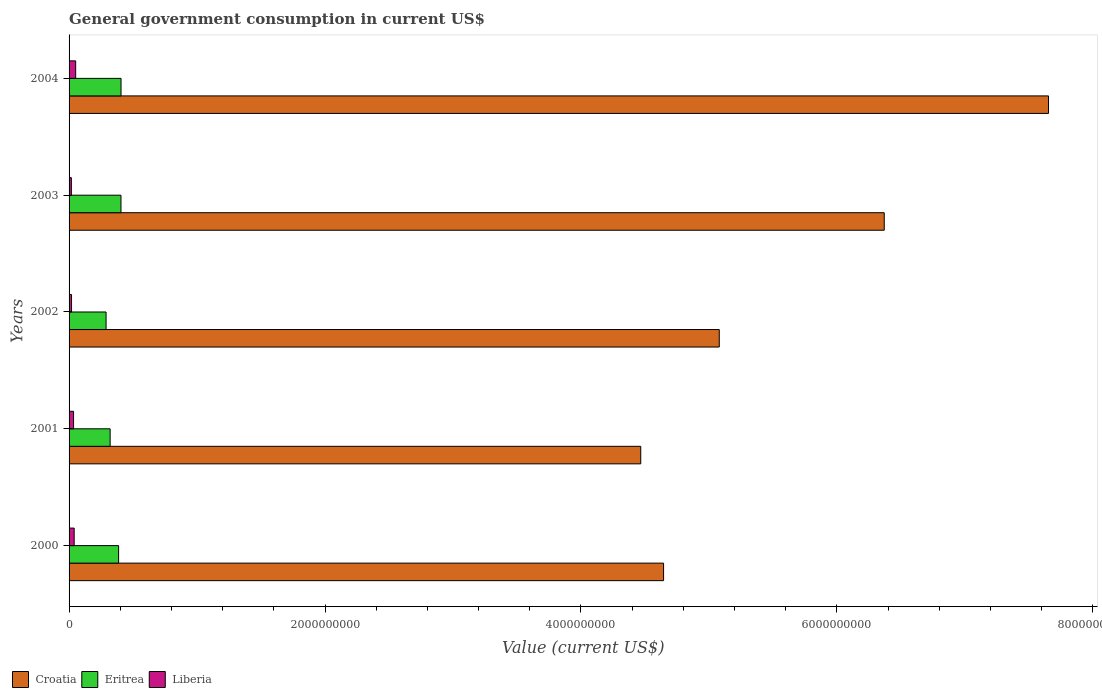How many different coloured bars are there?
Keep it short and to the point. 3. Are the number of bars per tick equal to the number of legend labels?
Provide a succinct answer. Yes. What is the government conusmption in Eritrea in 2002?
Your response must be concise. 2.89e+08. Across all years, what is the maximum government conusmption in Eritrea?
Make the answer very short. 4.06e+08. Across all years, what is the minimum government conusmption in Eritrea?
Keep it short and to the point. 2.89e+08. What is the total government conusmption in Eritrea in the graph?
Your answer should be compact. 1.81e+09. What is the difference between the government conusmption in Liberia in 2001 and that in 2003?
Provide a short and direct response. 1.72e+07. What is the difference between the government conusmption in Liberia in 2000 and the government conusmption in Eritrea in 2002?
Make the answer very short. -2.49e+08. What is the average government conusmption in Eritrea per year?
Your answer should be compact. 3.62e+08. In the year 2000, what is the difference between the government conusmption in Croatia and government conusmption in Eritrea?
Your answer should be compact. 4.26e+09. What is the ratio of the government conusmption in Eritrea in 2000 to that in 2001?
Offer a terse response. 1.21. Is the government conusmption in Eritrea in 2001 less than that in 2004?
Provide a short and direct response. Yes. Is the difference between the government conusmption in Croatia in 2001 and 2003 greater than the difference between the government conusmption in Eritrea in 2001 and 2003?
Ensure brevity in your answer.  No. What is the difference between the highest and the second highest government conusmption in Liberia?
Offer a terse response. 1.18e+07. What is the difference between the highest and the lowest government conusmption in Croatia?
Your response must be concise. 3.19e+09. In how many years, is the government conusmption in Croatia greater than the average government conusmption in Croatia taken over all years?
Ensure brevity in your answer.  2. What does the 2nd bar from the top in 2001 represents?
Offer a very short reply. Eritrea. What does the 1st bar from the bottom in 2002 represents?
Your response must be concise. Croatia. Is it the case that in every year, the sum of the government conusmption in Eritrea and government conusmption in Liberia is greater than the government conusmption in Croatia?
Your answer should be compact. No. Are all the bars in the graph horizontal?
Provide a succinct answer. Yes. What is the difference between two consecutive major ticks on the X-axis?
Give a very brief answer. 2.00e+09. Are the values on the major ticks of X-axis written in scientific E-notation?
Provide a short and direct response. No. Does the graph contain any zero values?
Provide a succinct answer. No. Does the graph contain grids?
Provide a succinct answer. No. How are the legend labels stacked?
Offer a very short reply. Horizontal. What is the title of the graph?
Provide a succinct answer. General government consumption in current US$. Does "Egypt, Arab Rep." appear as one of the legend labels in the graph?
Provide a short and direct response. No. What is the label or title of the X-axis?
Offer a very short reply. Value (current US$). What is the label or title of the Y-axis?
Your answer should be very brief. Years. What is the Value (current US$) of Croatia in 2000?
Provide a succinct answer. 4.65e+09. What is the Value (current US$) of Eritrea in 2000?
Your answer should be compact. 3.87e+08. What is the Value (current US$) of Liberia in 2000?
Give a very brief answer. 3.99e+07. What is the Value (current US$) of Croatia in 2001?
Make the answer very short. 4.47e+09. What is the Value (current US$) in Eritrea in 2001?
Provide a succinct answer. 3.21e+08. What is the Value (current US$) of Liberia in 2001?
Your answer should be very brief. 3.51e+07. What is the Value (current US$) in Croatia in 2002?
Give a very brief answer. 5.08e+09. What is the Value (current US$) of Eritrea in 2002?
Your answer should be compact. 2.89e+08. What is the Value (current US$) in Liberia in 2002?
Give a very brief answer. 1.92e+07. What is the Value (current US$) in Croatia in 2003?
Ensure brevity in your answer.  6.37e+09. What is the Value (current US$) of Eritrea in 2003?
Give a very brief answer. 4.06e+08. What is the Value (current US$) in Liberia in 2003?
Your response must be concise. 1.79e+07. What is the Value (current US$) in Croatia in 2004?
Your answer should be very brief. 7.65e+09. What is the Value (current US$) in Eritrea in 2004?
Offer a very short reply. 4.06e+08. What is the Value (current US$) of Liberia in 2004?
Your response must be concise. 5.16e+07. Across all years, what is the maximum Value (current US$) of Croatia?
Provide a short and direct response. 7.65e+09. Across all years, what is the maximum Value (current US$) in Eritrea?
Your response must be concise. 4.06e+08. Across all years, what is the maximum Value (current US$) in Liberia?
Keep it short and to the point. 5.16e+07. Across all years, what is the minimum Value (current US$) of Croatia?
Your answer should be compact. 4.47e+09. Across all years, what is the minimum Value (current US$) in Eritrea?
Give a very brief answer. 2.89e+08. Across all years, what is the minimum Value (current US$) in Liberia?
Offer a very short reply. 1.79e+07. What is the total Value (current US$) of Croatia in the graph?
Offer a very short reply. 2.82e+1. What is the total Value (current US$) in Eritrea in the graph?
Keep it short and to the point. 1.81e+09. What is the total Value (current US$) in Liberia in the graph?
Provide a succinct answer. 1.64e+08. What is the difference between the Value (current US$) of Croatia in 2000 and that in 2001?
Offer a very short reply. 1.78e+08. What is the difference between the Value (current US$) of Eritrea in 2000 and that in 2001?
Keep it short and to the point. 6.62e+07. What is the difference between the Value (current US$) in Liberia in 2000 and that in 2001?
Your answer should be compact. 4.77e+06. What is the difference between the Value (current US$) of Croatia in 2000 and that in 2002?
Provide a short and direct response. -4.35e+08. What is the difference between the Value (current US$) of Eritrea in 2000 and that in 2002?
Provide a short and direct response. 9.78e+07. What is the difference between the Value (current US$) of Liberia in 2000 and that in 2002?
Keep it short and to the point. 2.06e+07. What is the difference between the Value (current US$) in Croatia in 2000 and that in 2003?
Your response must be concise. -1.72e+09. What is the difference between the Value (current US$) of Eritrea in 2000 and that in 2003?
Your response must be concise. -1.85e+07. What is the difference between the Value (current US$) in Liberia in 2000 and that in 2003?
Ensure brevity in your answer.  2.19e+07. What is the difference between the Value (current US$) in Croatia in 2000 and that in 2004?
Provide a succinct answer. -3.01e+09. What is the difference between the Value (current US$) of Eritrea in 2000 and that in 2004?
Your answer should be very brief. -1.90e+07. What is the difference between the Value (current US$) of Liberia in 2000 and that in 2004?
Keep it short and to the point. -1.18e+07. What is the difference between the Value (current US$) of Croatia in 2001 and that in 2002?
Your answer should be compact. -6.14e+08. What is the difference between the Value (current US$) in Eritrea in 2001 and that in 2002?
Ensure brevity in your answer.  3.17e+07. What is the difference between the Value (current US$) of Liberia in 2001 and that in 2002?
Your answer should be compact. 1.58e+07. What is the difference between the Value (current US$) of Croatia in 2001 and that in 2003?
Your response must be concise. -1.90e+09. What is the difference between the Value (current US$) of Eritrea in 2001 and that in 2003?
Offer a very short reply. -8.47e+07. What is the difference between the Value (current US$) of Liberia in 2001 and that in 2003?
Provide a short and direct response. 1.72e+07. What is the difference between the Value (current US$) of Croatia in 2001 and that in 2004?
Keep it short and to the point. -3.19e+09. What is the difference between the Value (current US$) in Eritrea in 2001 and that in 2004?
Your response must be concise. -8.52e+07. What is the difference between the Value (current US$) of Liberia in 2001 and that in 2004?
Your answer should be compact. -1.66e+07. What is the difference between the Value (current US$) in Croatia in 2002 and that in 2003?
Make the answer very short. -1.29e+09. What is the difference between the Value (current US$) of Eritrea in 2002 and that in 2003?
Provide a succinct answer. -1.16e+08. What is the difference between the Value (current US$) in Liberia in 2002 and that in 2003?
Offer a very short reply. 1.33e+06. What is the difference between the Value (current US$) of Croatia in 2002 and that in 2004?
Ensure brevity in your answer.  -2.57e+09. What is the difference between the Value (current US$) of Eritrea in 2002 and that in 2004?
Offer a terse response. -1.17e+08. What is the difference between the Value (current US$) of Liberia in 2002 and that in 2004?
Give a very brief answer. -3.24e+07. What is the difference between the Value (current US$) of Croatia in 2003 and that in 2004?
Your answer should be very brief. -1.28e+09. What is the difference between the Value (current US$) in Eritrea in 2003 and that in 2004?
Your answer should be compact. -4.90e+05. What is the difference between the Value (current US$) in Liberia in 2003 and that in 2004?
Offer a very short reply. -3.37e+07. What is the difference between the Value (current US$) in Croatia in 2000 and the Value (current US$) in Eritrea in 2001?
Your answer should be compact. 4.32e+09. What is the difference between the Value (current US$) of Croatia in 2000 and the Value (current US$) of Liberia in 2001?
Make the answer very short. 4.61e+09. What is the difference between the Value (current US$) in Eritrea in 2000 and the Value (current US$) in Liberia in 2001?
Give a very brief answer. 3.52e+08. What is the difference between the Value (current US$) of Croatia in 2000 and the Value (current US$) of Eritrea in 2002?
Provide a short and direct response. 4.36e+09. What is the difference between the Value (current US$) of Croatia in 2000 and the Value (current US$) of Liberia in 2002?
Ensure brevity in your answer.  4.63e+09. What is the difference between the Value (current US$) of Eritrea in 2000 and the Value (current US$) of Liberia in 2002?
Ensure brevity in your answer.  3.68e+08. What is the difference between the Value (current US$) of Croatia in 2000 and the Value (current US$) of Eritrea in 2003?
Offer a terse response. 4.24e+09. What is the difference between the Value (current US$) of Croatia in 2000 and the Value (current US$) of Liberia in 2003?
Keep it short and to the point. 4.63e+09. What is the difference between the Value (current US$) of Eritrea in 2000 and the Value (current US$) of Liberia in 2003?
Offer a terse response. 3.69e+08. What is the difference between the Value (current US$) in Croatia in 2000 and the Value (current US$) in Eritrea in 2004?
Keep it short and to the point. 4.24e+09. What is the difference between the Value (current US$) of Croatia in 2000 and the Value (current US$) of Liberia in 2004?
Offer a very short reply. 4.59e+09. What is the difference between the Value (current US$) in Eritrea in 2000 and the Value (current US$) in Liberia in 2004?
Provide a succinct answer. 3.35e+08. What is the difference between the Value (current US$) in Croatia in 2001 and the Value (current US$) in Eritrea in 2002?
Keep it short and to the point. 4.18e+09. What is the difference between the Value (current US$) in Croatia in 2001 and the Value (current US$) in Liberia in 2002?
Keep it short and to the point. 4.45e+09. What is the difference between the Value (current US$) of Eritrea in 2001 and the Value (current US$) of Liberia in 2002?
Provide a succinct answer. 3.02e+08. What is the difference between the Value (current US$) of Croatia in 2001 and the Value (current US$) of Eritrea in 2003?
Give a very brief answer. 4.06e+09. What is the difference between the Value (current US$) of Croatia in 2001 and the Value (current US$) of Liberia in 2003?
Keep it short and to the point. 4.45e+09. What is the difference between the Value (current US$) of Eritrea in 2001 and the Value (current US$) of Liberia in 2003?
Your response must be concise. 3.03e+08. What is the difference between the Value (current US$) of Croatia in 2001 and the Value (current US$) of Eritrea in 2004?
Your response must be concise. 4.06e+09. What is the difference between the Value (current US$) in Croatia in 2001 and the Value (current US$) in Liberia in 2004?
Your response must be concise. 4.42e+09. What is the difference between the Value (current US$) in Eritrea in 2001 and the Value (current US$) in Liberia in 2004?
Ensure brevity in your answer.  2.69e+08. What is the difference between the Value (current US$) in Croatia in 2002 and the Value (current US$) in Eritrea in 2003?
Keep it short and to the point. 4.68e+09. What is the difference between the Value (current US$) of Croatia in 2002 and the Value (current US$) of Liberia in 2003?
Offer a very short reply. 5.06e+09. What is the difference between the Value (current US$) in Eritrea in 2002 and the Value (current US$) in Liberia in 2003?
Provide a short and direct response. 2.71e+08. What is the difference between the Value (current US$) of Croatia in 2002 and the Value (current US$) of Eritrea in 2004?
Ensure brevity in your answer.  4.67e+09. What is the difference between the Value (current US$) of Croatia in 2002 and the Value (current US$) of Liberia in 2004?
Provide a succinct answer. 5.03e+09. What is the difference between the Value (current US$) of Eritrea in 2002 and the Value (current US$) of Liberia in 2004?
Keep it short and to the point. 2.38e+08. What is the difference between the Value (current US$) in Croatia in 2003 and the Value (current US$) in Eritrea in 2004?
Provide a succinct answer. 5.96e+09. What is the difference between the Value (current US$) in Croatia in 2003 and the Value (current US$) in Liberia in 2004?
Provide a succinct answer. 6.32e+09. What is the difference between the Value (current US$) of Eritrea in 2003 and the Value (current US$) of Liberia in 2004?
Keep it short and to the point. 3.54e+08. What is the average Value (current US$) of Croatia per year?
Ensure brevity in your answer.  5.64e+09. What is the average Value (current US$) of Eritrea per year?
Ensure brevity in your answer.  3.62e+08. What is the average Value (current US$) in Liberia per year?
Your answer should be compact. 3.27e+07. In the year 2000, what is the difference between the Value (current US$) of Croatia and Value (current US$) of Eritrea?
Provide a succinct answer. 4.26e+09. In the year 2000, what is the difference between the Value (current US$) of Croatia and Value (current US$) of Liberia?
Ensure brevity in your answer.  4.61e+09. In the year 2000, what is the difference between the Value (current US$) of Eritrea and Value (current US$) of Liberia?
Keep it short and to the point. 3.47e+08. In the year 2001, what is the difference between the Value (current US$) of Croatia and Value (current US$) of Eritrea?
Ensure brevity in your answer.  4.15e+09. In the year 2001, what is the difference between the Value (current US$) of Croatia and Value (current US$) of Liberia?
Your response must be concise. 4.43e+09. In the year 2001, what is the difference between the Value (current US$) of Eritrea and Value (current US$) of Liberia?
Provide a short and direct response. 2.86e+08. In the year 2002, what is the difference between the Value (current US$) in Croatia and Value (current US$) in Eritrea?
Offer a terse response. 4.79e+09. In the year 2002, what is the difference between the Value (current US$) in Croatia and Value (current US$) in Liberia?
Give a very brief answer. 5.06e+09. In the year 2002, what is the difference between the Value (current US$) in Eritrea and Value (current US$) in Liberia?
Give a very brief answer. 2.70e+08. In the year 2003, what is the difference between the Value (current US$) of Croatia and Value (current US$) of Eritrea?
Provide a short and direct response. 5.96e+09. In the year 2003, what is the difference between the Value (current US$) of Croatia and Value (current US$) of Liberia?
Provide a succinct answer. 6.35e+09. In the year 2003, what is the difference between the Value (current US$) in Eritrea and Value (current US$) in Liberia?
Offer a very short reply. 3.88e+08. In the year 2004, what is the difference between the Value (current US$) in Croatia and Value (current US$) in Eritrea?
Provide a short and direct response. 7.25e+09. In the year 2004, what is the difference between the Value (current US$) of Croatia and Value (current US$) of Liberia?
Keep it short and to the point. 7.60e+09. In the year 2004, what is the difference between the Value (current US$) in Eritrea and Value (current US$) in Liberia?
Make the answer very short. 3.54e+08. What is the ratio of the Value (current US$) of Croatia in 2000 to that in 2001?
Offer a terse response. 1.04. What is the ratio of the Value (current US$) in Eritrea in 2000 to that in 2001?
Make the answer very short. 1.21. What is the ratio of the Value (current US$) of Liberia in 2000 to that in 2001?
Offer a terse response. 1.14. What is the ratio of the Value (current US$) of Croatia in 2000 to that in 2002?
Your answer should be compact. 0.91. What is the ratio of the Value (current US$) of Eritrea in 2000 to that in 2002?
Give a very brief answer. 1.34. What is the ratio of the Value (current US$) of Liberia in 2000 to that in 2002?
Your answer should be very brief. 2.07. What is the ratio of the Value (current US$) in Croatia in 2000 to that in 2003?
Ensure brevity in your answer.  0.73. What is the ratio of the Value (current US$) in Eritrea in 2000 to that in 2003?
Ensure brevity in your answer.  0.95. What is the ratio of the Value (current US$) in Liberia in 2000 to that in 2003?
Keep it short and to the point. 2.23. What is the ratio of the Value (current US$) of Croatia in 2000 to that in 2004?
Offer a very short reply. 0.61. What is the ratio of the Value (current US$) in Eritrea in 2000 to that in 2004?
Make the answer very short. 0.95. What is the ratio of the Value (current US$) of Liberia in 2000 to that in 2004?
Keep it short and to the point. 0.77. What is the ratio of the Value (current US$) of Croatia in 2001 to that in 2002?
Your answer should be very brief. 0.88. What is the ratio of the Value (current US$) in Eritrea in 2001 to that in 2002?
Offer a very short reply. 1.11. What is the ratio of the Value (current US$) in Liberia in 2001 to that in 2002?
Give a very brief answer. 1.82. What is the ratio of the Value (current US$) of Croatia in 2001 to that in 2003?
Provide a succinct answer. 0.7. What is the ratio of the Value (current US$) of Eritrea in 2001 to that in 2003?
Make the answer very short. 0.79. What is the ratio of the Value (current US$) of Liberia in 2001 to that in 2003?
Provide a short and direct response. 1.96. What is the ratio of the Value (current US$) of Croatia in 2001 to that in 2004?
Give a very brief answer. 0.58. What is the ratio of the Value (current US$) of Eritrea in 2001 to that in 2004?
Your answer should be compact. 0.79. What is the ratio of the Value (current US$) of Liberia in 2001 to that in 2004?
Give a very brief answer. 0.68. What is the ratio of the Value (current US$) in Croatia in 2002 to that in 2003?
Provide a short and direct response. 0.8. What is the ratio of the Value (current US$) in Eritrea in 2002 to that in 2003?
Offer a terse response. 0.71. What is the ratio of the Value (current US$) of Liberia in 2002 to that in 2003?
Your response must be concise. 1.07. What is the ratio of the Value (current US$) in Croatia in 2002 to that in 2004?
Ensure brevity in your answer.  0.66. What is the ratio of the Value (current US$) in Eritrea in 2002 to that in 2004?
Keep it short and to the point. 0.71. What is the ratio of the Value (current US$) of Liberia in 2002 to that in 2004?
Ensure brevity in your answer.  0.37. What is the ratio of the Value (current US$) in Croatia in 2003 to that in 2004?
Your answer should be very brief. 0.83. What is the ratio of the Value (current US$) of Liberia in 2003 to that in 2004?
Your answer should be compact. 0.35. What is the difference between the highest and the second highest Value (current US$) of Croatia?
Make the answer very short. 1.28e+09. What is the difference between the highest and the second highest Value (current US$) of Eritrea?
Your response must be concise. 4.90e+05. What is the difference between the highest and the second highest Value (current US$) of Liberia?
Provide a short and direct response. 1.18e+07. What is the difference between the highest and the lowest Value (current US$) in Croatia?
Offer a terse response. 3.19e+09. What is the difference between the highest and the lowest Value (current US$) of Eritrea?
Provide a succinct answer. 1.17e+08. What is the difference between the highest and the lowest Value (current US$) of Liberia?
Offer a terse response. 3.37e+07. 